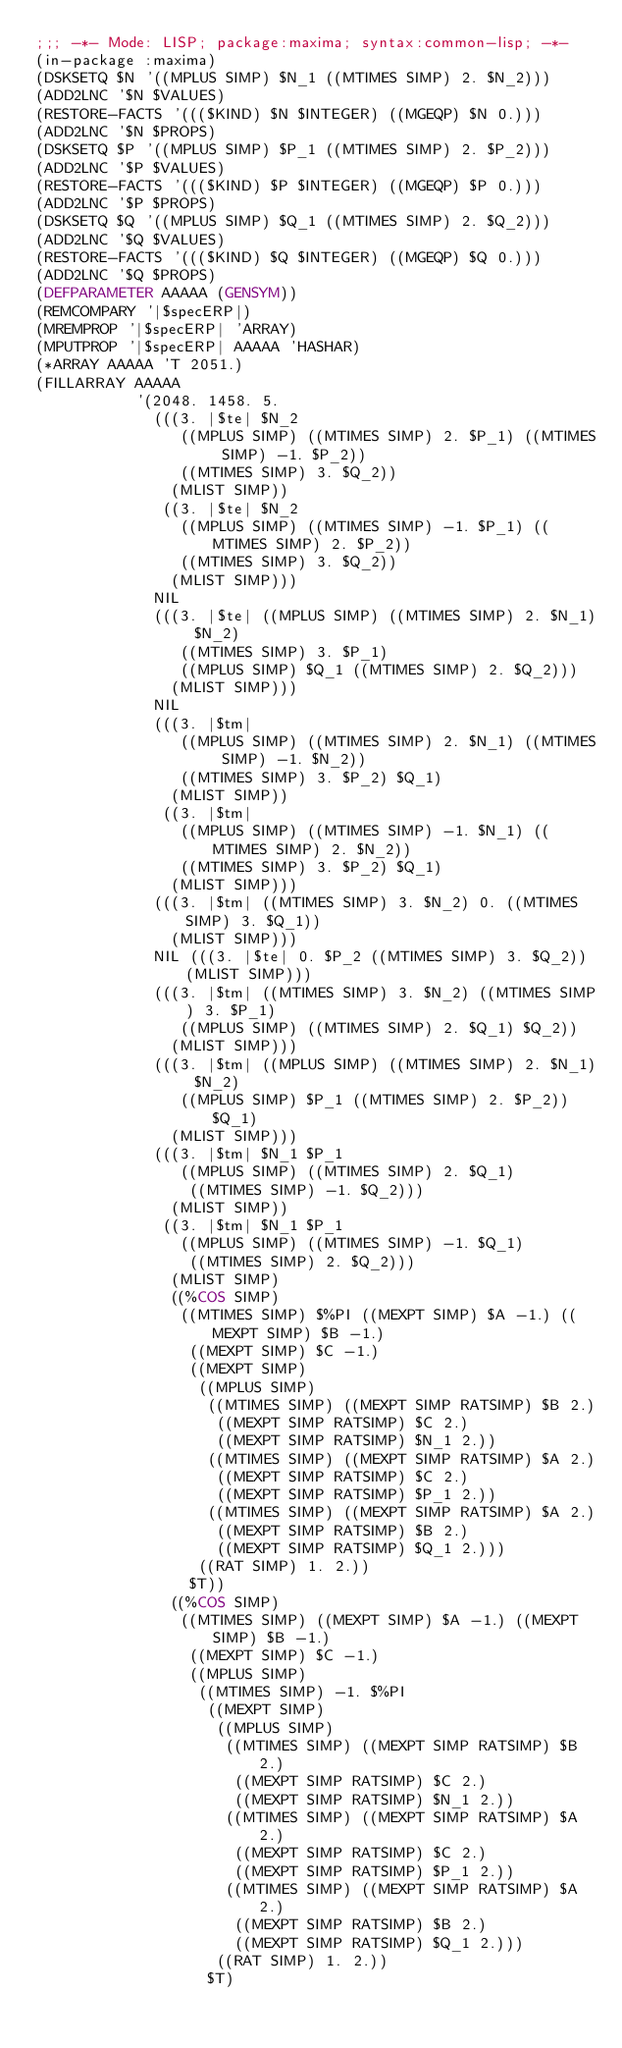Convert code to text. <code><loc_0><loc_0><loc_500><loc_500><_Lisp_>;;; -*- Mode: LISP; package:maxima; syntax:common-lisp; -*- 
(in-package :maxima)
(DSKSETQ $N '((MPLUS SIMP) $N_1 ((MTIMES SIMP) 2. $N_2))) 
(ADD2LNC '$N $VALUES) 
(RESTORE-FACTS '((($KIND) $N $INTEGER) ((MGEQP) $N 0.))) 
(ADD2LNC '$N $PROPS) 
(DSKSETQ $P '((MPLUS SIMP) $P_1 ((MTIMES SIMP) 2. $P_2))) 
(ADD2LNC '$P $VALUES) 
(RESTORE-FACTS '((($KIND) $P $INTEGER) ((MGEQP) $P 0.))) 
(ADD2LNC '$P $PROPS) 
(DSKSETQ $Q '((MPLUS SIMP) $Q_1 ((MTIMES SIMP) 2. $Q_2))) 
(ADD2LNC '$Q $VALUES) 
(RESTORE-FACTS '((($KIND) $Q $INTEGER) ((MGEQP) $Q 0.))) 
(ADD2LNC '$Q $PROPS) 
(DEFPARAMETER AAAAA (GENSYM)) 
(REMCOMPARY '|$specERP|) 
(MREMPROP '|$specERP| 'ARRAY) 
(MPUTPROP '|$specERP| AAAAA 'HASHAR) 
(*ARRAY AAAAA 'T 2051.) 
(FILLARRAY AAAAA
           '(2048. 1458. 5.
             (((3. |$te| $N_2
                ((MPLUS SIMP) ((MTIMES SIMP) 2. $P_1) ((MTIMES SIMP) -1. $P_2))
                ((MTIMES SIMP) 3. $Q_2))
               (MLIST SIMP))
              ((3. |$te| $N_2
                ((MPLUS SIMP) ((MTIMES SIMP) -1. $P_1) ((MTIMES SIMP) 2. $P_2))
                ((MTIMES SIMP) 3. $Q_2))
               (MLIST SIMP)))
             NIL
             (((3. |$te| ((MPLUS SIMP) ((MTIMES SIMP) 2. $N_1) $N_2)
                ((MTIMES SIMP) 3. $P_1)
                ((MPLUS SIMP) $Q_1 ((MTIMES SIMP) 2. $Q_2)))
               (MLIST SIMP)))
             NIL
             (((3. |$tm|
                ((MPLUS SIMP) ((MTIMES SIMP) 2. $N_1) ((MTIMES SIMP) -1. $N_2))
                ((MTIMES SIMP) 3. $P_2) $Q_1)
               (MLIST SIMP))
              ((3. |$tm|
                ((MPLUS SIMP) ((MTIMES SIMP) -1. $N_1) ((MTIMES SIMP) 2. $N_2))
                ((MTIMES SIMP) 3. $P_2) $Q_1)
               (MLIST SIMP)))
             (((3. |$tm| ((MTIMES SIMP) 3. $N_2) 0. ((MTIMES SIMP) 3. $Q_1))
               (MLIST SIMP)))
             NIL (((3. |$te| 0. $P_2 ((MTIMES SIMP) 3. $Q_2)) (MLIST SIMP)))
             (((3. |$tm| ((MTIMES SIMP) 3. $N_2) ((MTIMES SIMP) 3. $P_1)
                ((MPLUS SIMP) ((MTIMES SIMP) 2. $Q_1) $Q_2))
               (MLIST SIMP)))
             (((3. |$tm| ((MPLUS SIMP) ((MTIMES SIMP) 2. $N_1) $N_2)
                ((MPLUS SIMP) $P_1 ((MTIMES SIMP) 2. $P_2)) $Q_1)
               (MLIST SIMP)))
             (((3. |$tm| $N_1 $P_1
                ((MPLUS SIMP) ((MTIMES SIMP) 2. $Q_1)
                 ((MTIMES SIMP) -1. $Q_2)))
               (MLIST SIMP))
              ((3. |$tm| $N_1 $P_1
                ((MPLUS SIMP) ((MTIMES SIMP) -1. $Q_1)
                 ((MTIMES SIMP) 2. $Q_2)))
               (MLIST SIMP)
               ((%COS SIMP)
                ((MTIMES SIMP) $%PI ((MEXPT SIMP) $A -1.) ((MEXPT SIMP) $B -1.)
                 ((MEXPT SIMP) $C -1.)
                 ((MEXPT SIMP)
                  ((MPLUS SIMP)
                   ((MTIMES SIMP) ((MEXPT SIMP RATSIMP) $B 2.)
                    ((MEXPT SIMP RATSIMP) $C 2.)
                    ((MEXPT SIMP RATSIMP) $N_1 2.))
                   ((MTIMES SIMP) ((MEXPT SIMP RATSIMP) $A 2.)
                    ((MEXPT SIMP RATSIMP) $C 2.)
                    ((MEXPT SIMP RATSIMP) $P_1 2.))
                   ((MTIMES SIMP) ((MEXPT SIMP RATSIMP) $A 2.)
                    ((MEXPT SIMP RATSIMP) $B 2.)
                    ((MEXPT SIMP RATSIMP) $Q_1 2.)))
                  ((RAT SIMP) 1. 2.))
                 $T))
               ((%COS SIMP)
                ((MTIMES SIMP) ((MEXPT SIMP) $A -1.) ((MEXPT SIMP) $B -1.)
                 ((MEXPT SIMP) $C -1.)
                 ((MPLUS SIMP)
                  ((MTIMES SIMP) -1. $%PI
                   ((MEXPT SIMP)
                    ((MPLUS SIMP)
                     ((MTIMES SIMP) ((MEXPT SIMP RATSIMP) $B 2.)
                      ((MEXPT SIMP RATSIMP) $C 2.)
                      ((MEXPT SIMP RATSIMP) $N_1 2.))
                     ((MTIMES SIMP) ((MEXPT SIMP RATSIMP) $A 2.)
                      ((MEXPT SIMP RATSIMP) $C 2.)
                      ((MEXPT SIMP RATSIMP) $P_1 2.))
                     ((MTIMES SIMP) ((MEXPT SIMP RATSIMP) $A 2.)
                      ((MEXPT SIMP RATSIMP) $B 2.)
                      ((MEXPT SIMP RATSIMP) $Q_1 2.)))
                    ((RAT SIMP) 1. 2.))
                   $T)</code> 